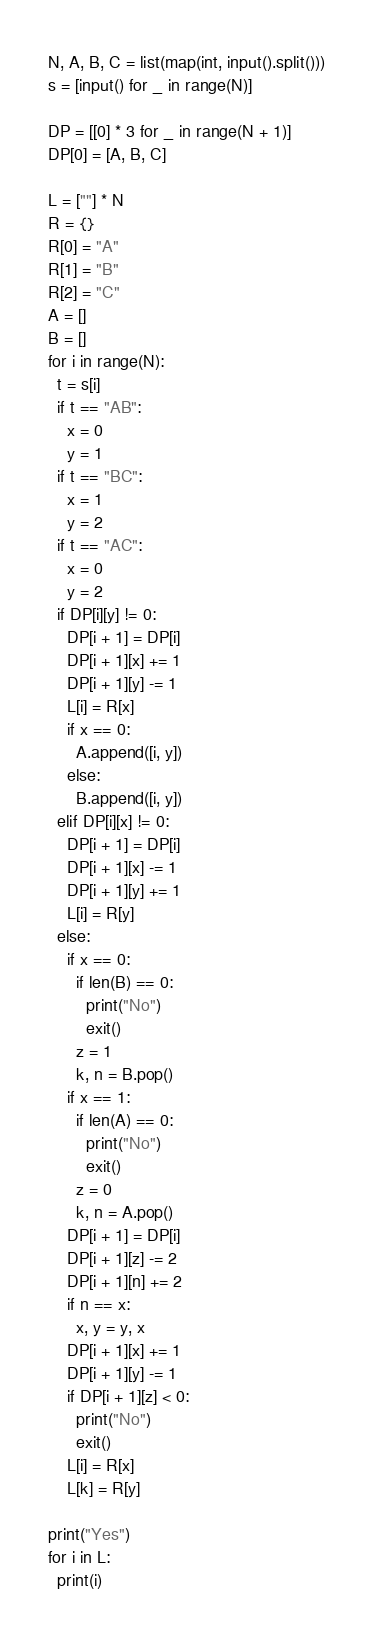Convert code to text. <code><loc_0><loc_0><loc_500><loc_500><_Python_>N, A, B, C = list(map(int, input().split()))
s = [input() for _ in range(N)]

DP = [[0] * 3 for _ in range(N + 1)]
DP[0] = [A, B, C]

L = [""] * N
R = {}
R[0] = "A"
R[1] = "B"
R[2] = "C"
A = []
B = []
for i in range(N):
  t = s[i]
  if t == "AB":
    x = 0
    y = 1
  if t == "BC":
    x = 1
    y = 2
  if t == "AC":
    x = 0
    y = 2
  if DP[i][y] != 0:
    DP[i + 1] = DP[i]
    DP[i + 1][x] += 1
    DP[i + 1][y] -= 1
    L[i] = R[x]
    if x == 0:
      A.append([i, y])
    else:
      B.append([i, y])
  elif DP[i][x] != 0:
    DP[i + 1] = DP[i]
    DP[i + 1][x] -= 1
    DP[i + 1][y] += 1
    L[i] = R[y]
  else:
    if x == 0:
      if len(B) == 0:
        print("No")
        exit()
      z = 1
      k, n = B.pop()
    if x == 1:
      if len(A) == 0:
        print("No")
        exit()
      z = 0
      k, n = A.pop()
    DP[i + 1] = DP[i]
    DP[i + 1][z] -= 2
    DP[i + 1][n] += 2
    if n == x:
      x, y = y, x
    DP[i + 1][x] += 1
    DP[i + 1][y] -= 1
    if DP[i + 1][z] < 0:
      print("No")
      exit()
    L[i] = R[x]
    L[k] = R[y]

print("Yes")
for i in L:
  print(i)

</code> 